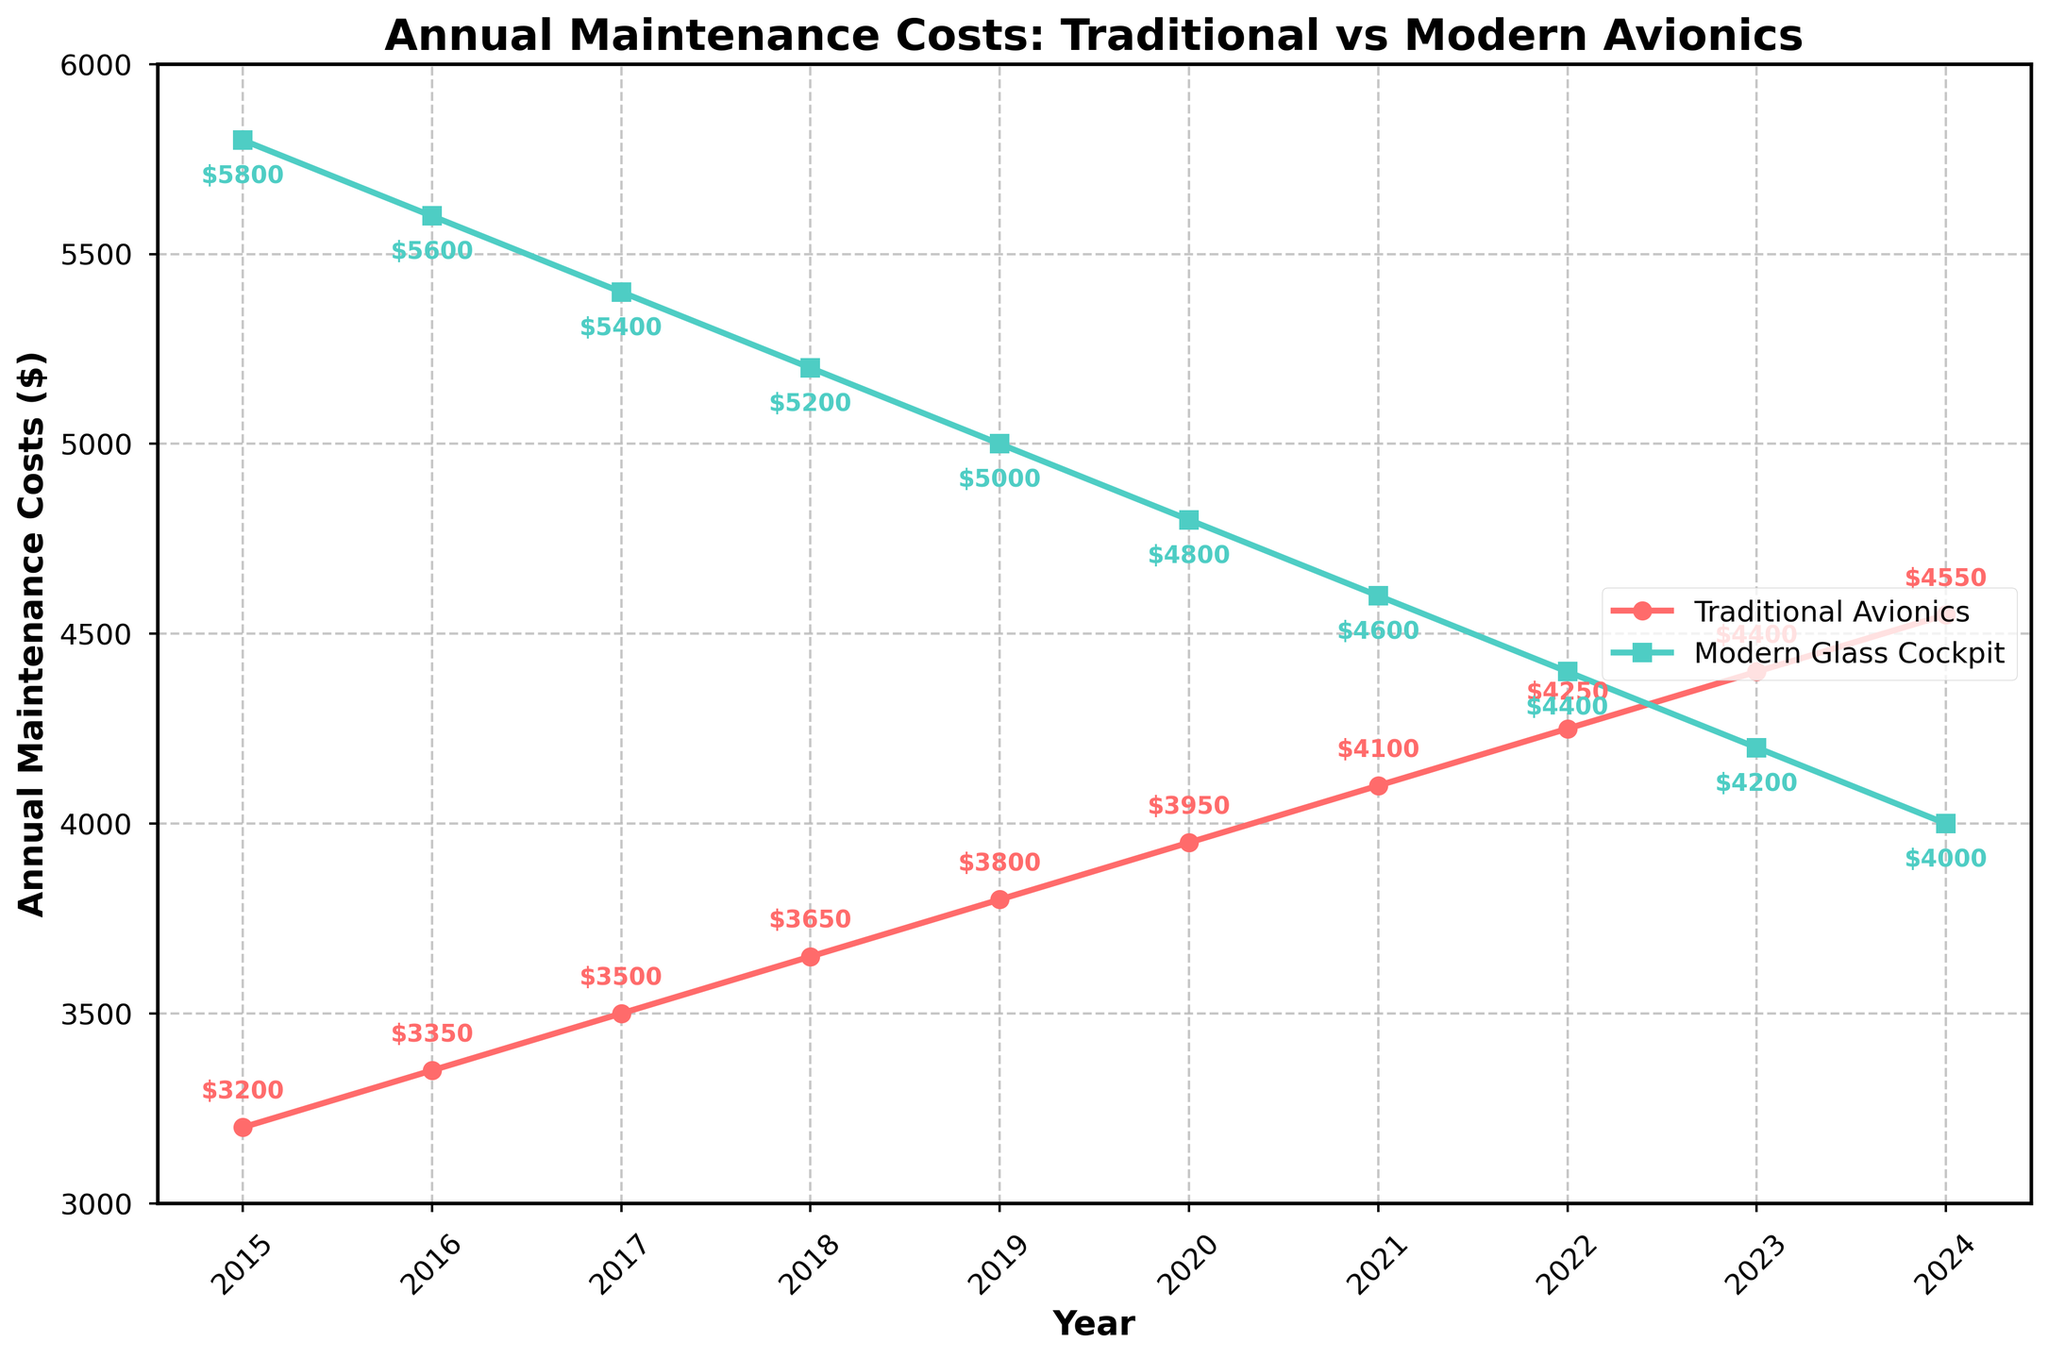Which avionics system had higher maintenance costs in 2015? In 2015, the line representing Traditional Avionics is higher on the y-axis compared to Modern Glass Cockpit, indicating higher costs.
Answer: Traditional Avionics By how much did the maintenance costs for Modern Glass Cockpit decrease from 2015 to 2024? The costs for Modern Glass Cockpit in 2015 were $5800, and in 2024 they are $4000. The difference is $5800 - $4000.
Answer: $1800 What is the trend of maintenance costs for Traditional Avionics from 2015 to 2024? Observing the trend line for Traditional Avionics, it clearly increases each year from 2015 ($3200) to 2024 ($4550).
Answer: Increasing In which year do the maintenance costs of Modern Glass Cockpit become lower than Traditional Avionics? Observing the intersection of the two lines, we see that around 2023 the Modern Glass Cockpit costs ($4200) become lower than Traditional Avionics costs ($4400).
Answer: 2023 What is the difference in maintenance costs between Traditional Avionics and Modern Glass Cockpit in 2020? The costs in 2020 for Traditional Avionics are $3950 and for Modern Glass Cockpit are $4800. The difference is $4800 - $3950.
Answer: $850 Which avionics system shows a more significant decrease in maintenance costs over the years? By comparing the lines, Modern Glass Cockpit shows a significant decrease from $5800 in 2015 to $4000 in 2024, whereas Traditional Avionics shows an increase.
Answer: Modern Glass Cockpit How did the maintenance costs for Modern Glass Cockpit change between 2016 and 2021? The Modern Glass Cockpit costs were $5600 in 2016 and reduced progressively each year to $4600 in 2021.
Answer: Decreased What is the combined maintenance cost for both avionics systems in 2017? For 2017, Traditional Avionics costs $3500 and Modern Glass Cockpit costs $5400. Adding these values together gives $3500 + $5400.
Answer: $8900 During which years were the costs for Modern Glass Cockpit consistently decreasing? By following the trend line for Modern Glass Cockpit, it is consistently decreasing from 2015 to 2024.
Answer: 2015 to 2024 How much did the maintenance costs for Traditional Avionics increase from 2017 to 2020? Traditional Avionics costs were $3500 in 2017 and $3950 in 2020. The increase is $3950 - $3500.
Answer: $450 